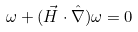<formula> <loc_0><loc_0><loc_500><loc_500>\omega + ( \vec { H } \cdot \hat { \nabla } ) \omega = 0</formula> 